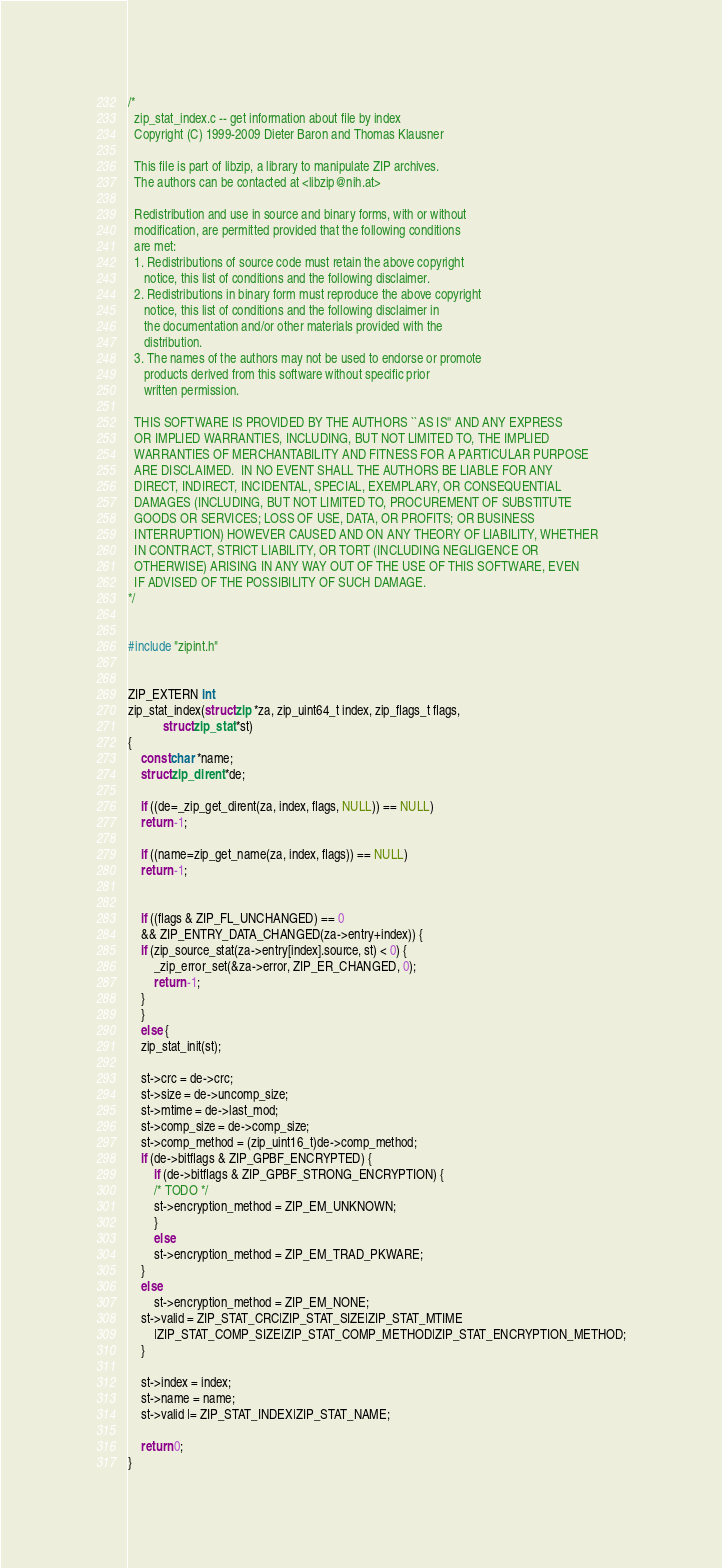<code> <loc_0><loc_0><loc_500><loc_500><_C_>/*
  zip_stat_index.c -- get information about file by index
  Copyright (C) 1999-2009 Dieter Baron and Thomas Klausner

  This file is part of libzip, a library to manipulate ZIP archives.
  The authors can be contacted at <libzip@nih.at>

  Redistribution and use in source and binary forms, with or without
  modification, are permitted provided that the following conditions
  are met:
  1. Redistributions of source code must retain the above copyright
     notice, this list of conditions and the following disclaimer.
  2. Redistributions in binary form must reproduce the above copyright
     notice, this list of conditions and the following disclaimer in
     the documentation and/or other materials provided with the
     distribution.
  3. The names of the authors may not be used to endorse or promote
     products derived from this software without specific prior
     written permission.
 
  THIS SOFTWARE IS PROVIDED BY THE AUTHORS ``AS IS'' AND ANY EXPRESS
  OR IMPLIED WARRANTIES, INCLUDING, BUT NOT LIMITED TO, THE IMPLIED
  WARRANTIES OF MERCHANTABILITY AND FITNESS FOR A PARTICULAR PURPOSE
  ARE DISCLAIMED.  IN NO EVENT SHALL THE AUTHORS BE LIABLE FOR ANY
  DIRECT, INDIRECT, INCIDENTAL, SPECIAL, EXEMPLARY, OR CONSEQUENTIAL
  DAMAGES (INCLUDING, BUT NOT LIMITED TO, PROCUREMENT OF SUBSTITUTE
  GOODS OR SERVICES; LOSS OF USE, DATA, OR PROFITS; OR BUSINESS
  INTERRUPTION) HOWEVER CAUSED AND ON ANY THEORY OF LIABILITY, WHETHER
  IN CONTRACT, STRICT LIABILITY, OR TORT (INCLUDING NEGLIGENCE OR
  OTHERWISE) ARISING IN ANY WAY OUT OF THE USE OF THIS SOFTWARE, EVEN
  IF ADVISED OF THE POSSIBILITY OF SUCH DAMAGE.
*/


#include "zipint.h"


ZIP_EXTERN int
zip_stat_index(struct zip *za, zip_uint64_t index, zip_flags_t flags,
	       struct zip_stat *st)
{
    const char *name;
    struct zip_dirent *de;

    if ((de=_zip_get_dirent(za, index, flags, NULL)) == NULL)
	return -1;

    if ((name=zip_get_name(za, index, flags)) == NULL)
	return -1;
    

    if ((flags & ZIP_FL_UNCHANGED) == 0
	&& ZIP_ENTRY_DATA_CHANGED(za->entry+index)) {
	if (zip_source_stat(za->entry[index].source, st) < 0) {
	    _zip_error_set(&za->error, ZIP_ER_CHANGED, 0);
	    return -1;
	}
    }
    else {
	zip_stat_init(st);

	st->crc = de->crc;
	st->size = de->uncomp_size;
	st->mtime = de->last_mod;
	st->comp_size = de->comp_size;
	st->comp_method = (zip_uint16_t)de->comp_method;
	if (de->bitflags & ZIP_GPBF_ENCRYPTED) {
	    if (de->bitflags & ZIP_GPBF_STRONG_ENCRYPTION) {
		/* TODO */
		st->encryption_method = ZIP_EM_UNKNOWN;
	    }
	    else
		st->encryption_method = ZIP_EM_TRAD_PKWARE;
	}
	else
	    st->encryption_method = ZIP_EM_NONE;
	st->valid = ZIP_STAT_CRC|ZIP_STAT_SIZE|ZIP_STAT_MTIME
	    |ZIP_STAT_COMP_SIZE|ZIP_STAT_COMP_METHOD|ZIP_STAT_ENCRYPTION_METHOD;
    }

    st->index = index;
    st->name = name;
    st->valid |= ZIP_STAT_INDEX|ZIP_STAT_NAME;
    
    return 0;
}
</code> 